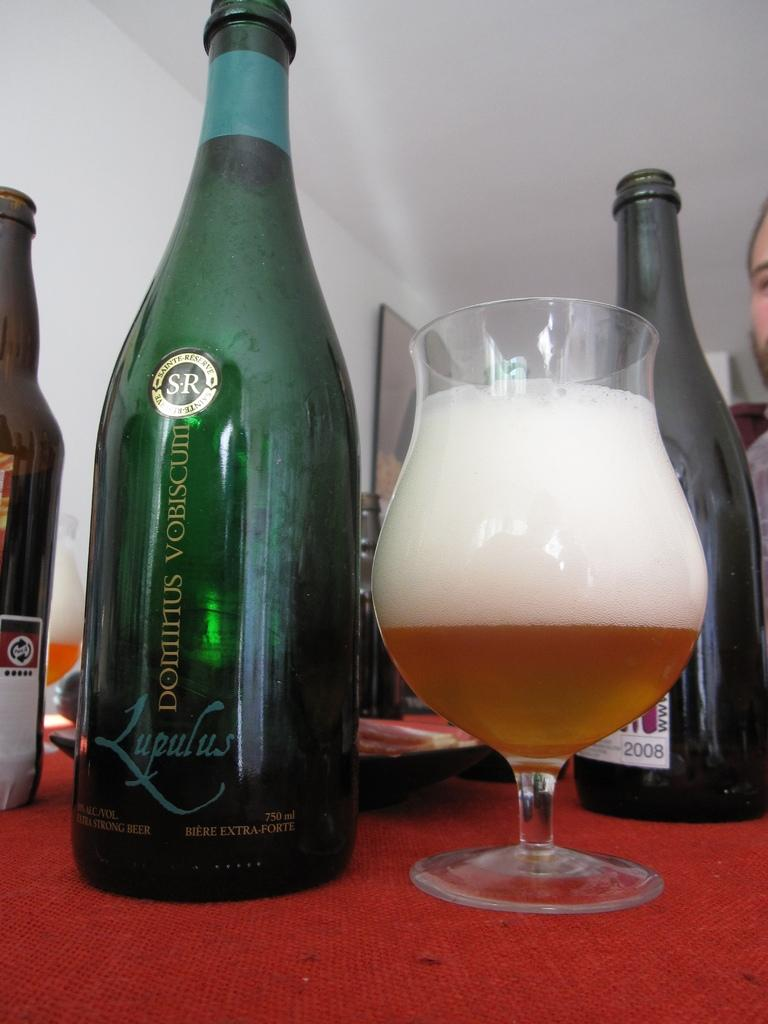What objects can be seen in the image that are typically used for holding liquids? There are bottles in the image that are typically used for holding liquids. What is on the table in the image? There is a glass on the table in the image. What can be seen in the background of the image? There is a wall in the background of the image. How is the image presented? The image is framed. What type of instrument is being played in the image? There is no instrument being played in the image. Can you tell me how many drawers are visible in the image? There are no drawers present in the image. 